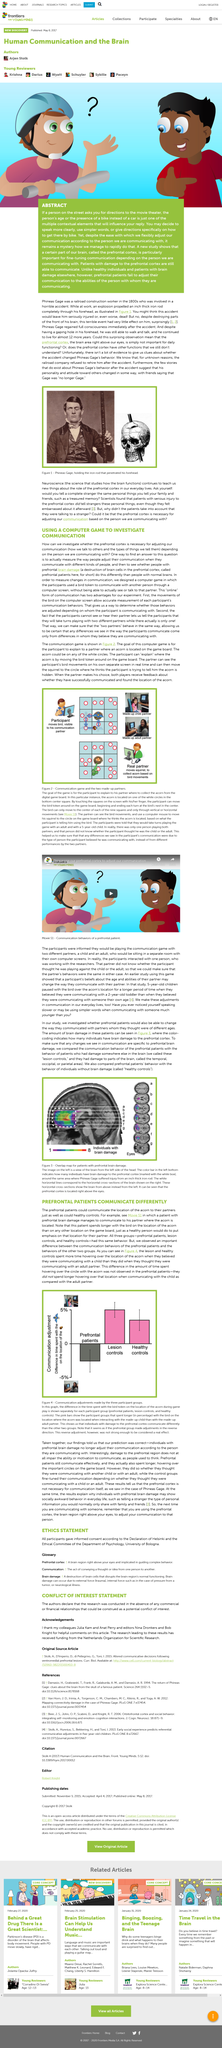Mention a couple of crucial points in this snapshot. The person in the photograph is Phineas Gage. Healthy controls are individuals without brain damage who serve as a reference point for comparing the behavior of patients with prefrontoal brain damage. The experiment involves participants who believe they are playing with two partners. Neuroscience is the scientific study of the brain and its functions. The study examined the differences in communication behavior between patients with damage to the prefrontal cortex and patients with damage to other areas of the brain. The results showed that patients with damage to the prefrontal cortex exhibited unique patterns of communication behavior compared to those with damage in other areas of the brain. 